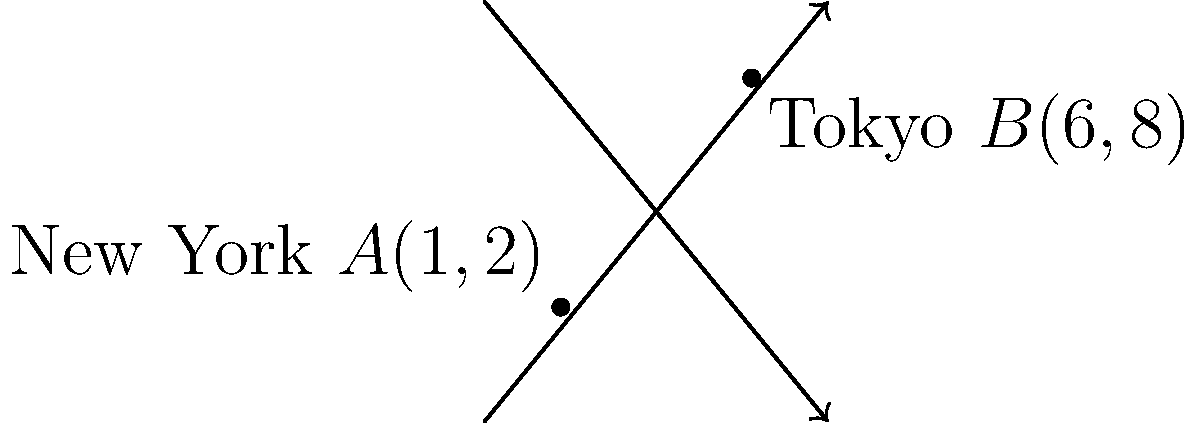On a simplified world map, New York is represented by the point $A(1,2)$ and Tokyo by the point $B(6,8)$, where the coordinates represent (longitude, latitude). Using the distance formula, calculate the straight-line distance between these two cities on this map. Round your answer to two decimal places. To find the distance between two points on a coordinate plane, we use the distance formula:

$$d = \sqrt{(x_2 - x_1)^2 + (y_2 - y_1)^2}$$

Where $(x_1, y_1)$ represents the coordinates of the first point and $(x_2, y_2)$ represents the coordinates of the second point.

Given:
- New York: $A(1,2)$
- Tokyo: $B(6,8)$

Let's plug these values into the formula:

$$\begin{align}
d &= \sqrt{(6 - 1)^2 + (8 - 2)^2} \\
&= \sqrt{5^2 + 6^2} \\
&= \sqrt{25 + 36} \\
&= \sqrt{61} \\
&\approx 7.81
\end{align}$$

Rounding to two decimal places, we get 7.81.

Note: This simplified model doesn't account for the Earth's curvature or the actual geographic distance between the cities. It's a straight-line distance on the given coordinate system.
Answer: 7.81 